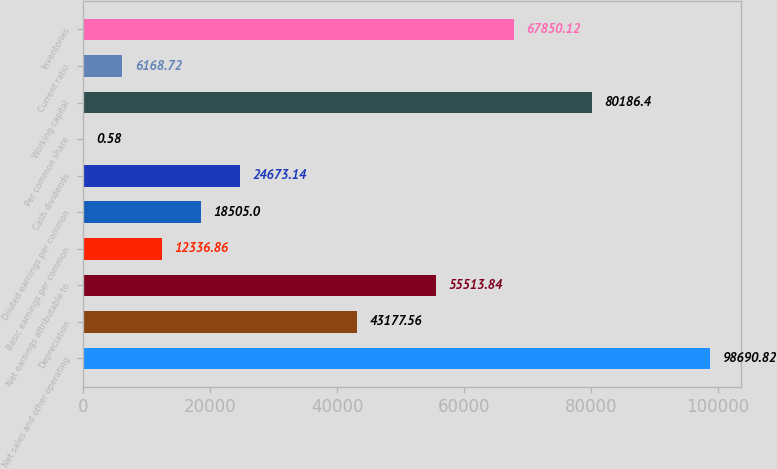Convert chart to OTSL. <chart><loc_0><loc_0><loc_500><loc_500><bar_chart><fcel>Net sales and other operating<fcel>Depreciation<fcel>Net earnings attributable to<fcel>Basic earnings per common<fcel>Diluted earnings per common<fcel>Cash dividends<fcel>Per common share<fcel>Working capital<fcel>Current ratio<fcel>Inventories<nl><fcel>98690.8<fcel>43177.6<fcel>55513.8<fcel>12336.9<fcel>18505<fcel>24673.1<fcel>0.58<fcel>80186.4<fcel>6168.72<fcel>67850.1<nl></chart> 